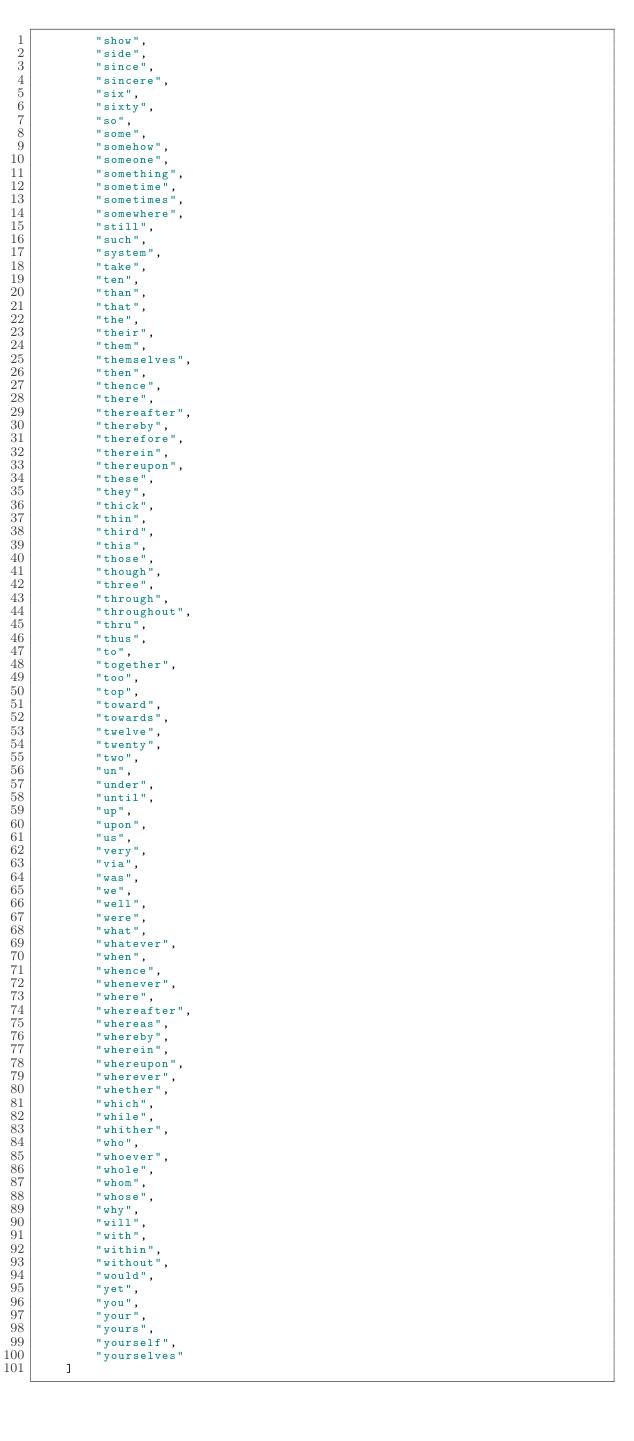Convert code to text. <code><loc_0><loc_0><loc_500><loc_500><_Python_>        "show",
        "side",
        "since",
        "sincere",
        "six",
        "sixty",
        "so",
        "some",
        "somehow",
        "someone",
        "something",
        "sometime",
        "sometimes",
        "somewhere",
        "still",
        "such",
        "system",
        "take",
        "ten",
        "than",
        "that",
        "the",
        "their",
        "them",
        "themselves",
        "then",
        "thence",
        "there",
        "thereafter",
        "thereby",
        "therefore",
        "therein",
        "thereupon",
        "these",
        "they",
        "thick",
        "thin",
        "third",
        "this",
        "those",
        "though",
        "three",
        "through",
        "throughout",
        "thru",
        "thus",
        "to",
        "together",
        "too",
        "top",
        "toward",
        "towards",
        "twelve",
        "twenty",
        "two",
        "un",
        "under",
        "until",
        "up",
        "upon",
        "us",
        "very",
        "via",
        "was",
        "we",
        "well",
        "were",
        "what",
        "whatever",
        "when",
        "whence",
        "whenever",
        "where",
        "whereafter",
        "whereas",
        "whereby",
        "wherein",
        "whereupon",
        "wherever",
        "whether",
        "which",
        "while",
        "whither",
        "who",
        "whoever",
        "whole",
        "whom",
        "whose",
        "why",
        "will",
        "with",
        "within",
        "without",
        "would",
        "yet",
        "you",
        "your",
        "yours",
        "yourself",
        "yourselves"
    ]
</code> 